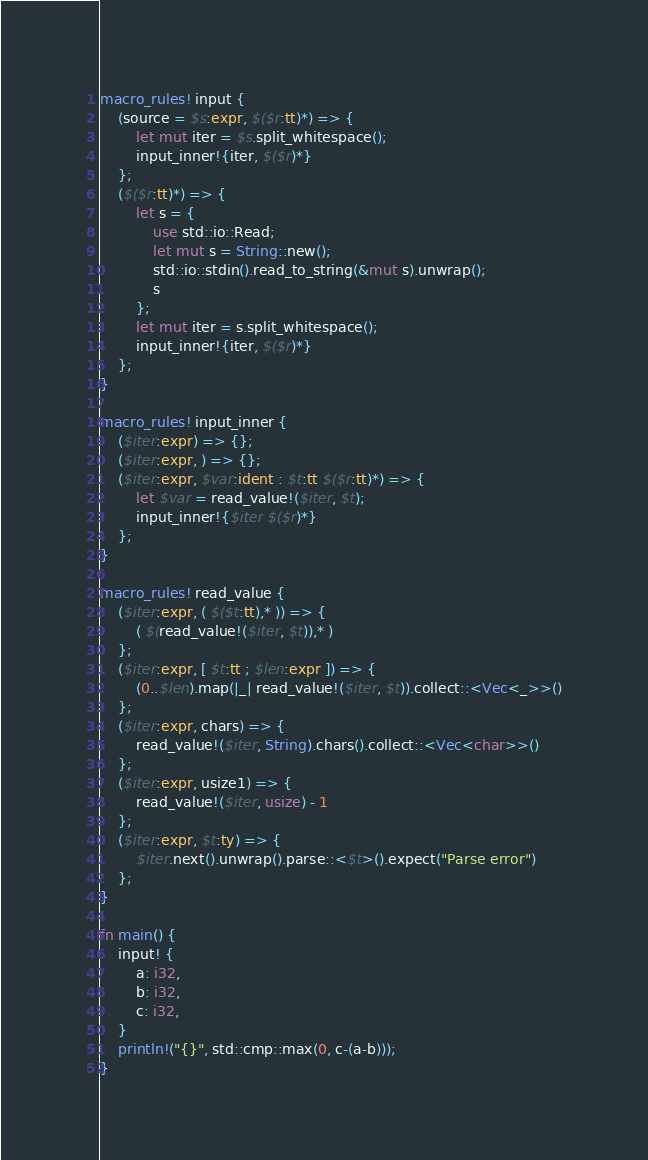<code> <loc_0><loc_0><loc_500><loc_500><_Rust_>macro_rules! input {
    (source = $s:expr, $($r:tt)*) => {
        let mut iter = $s.split_whitespace();
        input_inner!{iter, $($r)*}
    };
    ($($r:tt)*) => {
        let s = {
            use std::io::Read;
            let mut s = String::new();
            std::io::stdin().read_to_string(&mut s).unwrap();
            s
        };
        let mut iter = s.split_whitespace();
        input_inner!{iter, $($r)*}
    };
}

macro_rules! input_inner {
    ($iter:expr) => {};
    ($iter:expr, ) => {};
    ($iter:expr, $var:ident : $t:tt $($r:tt)*) => {
        let $var = read_value!($iter, $t);
        input_inner!{$iter $($r)*}
    };
}

macro_rules! read_value {
    ($iter:expr, ( $($t:tt),* )) => {
        ( $(read_value!($iter, $t)),* )
    };
    ($iter:expr, [ $t:tt ; $len:expr ]) => {
        (0..$len).map(|_| read_value!($iter, $t)).collect::<Vec<_>>()
    };
    ($iter:expr, chars) => {
        read_value!($iter, String).chars().collect::<Vec<char>>()
    };
    ($iter:expr, usize1) => {
        read_value!($iter, usize) - 1
    };
    ($iter:expr, $t:ty) => {
        $iter.next().unwrap().parse::<$t>().expect("Parse error")
    };
}

fn main() {
    input! {
        a: i32,
        b: i32,
        c: i32,
    }
    println!("{}", std::cmp::max(0, c-(a-b)));
}
</code> 